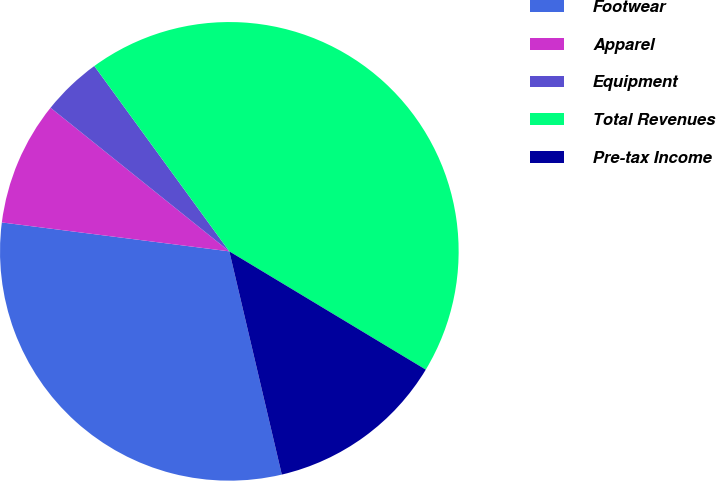Convert chart to OTSL. <chart><loc_0><loc_0><loc_500><loc_500><pie_chart><fcel>Footwear<fcel>Apparel<fcel>Equipment<fcel>Total Revenues<fcel>Pre-tax Income<nl><fcel>30.69%<fcel>8.76%<fcel>4.21%<fcel>43.65%<fcel>12.7%<nl></chart> 